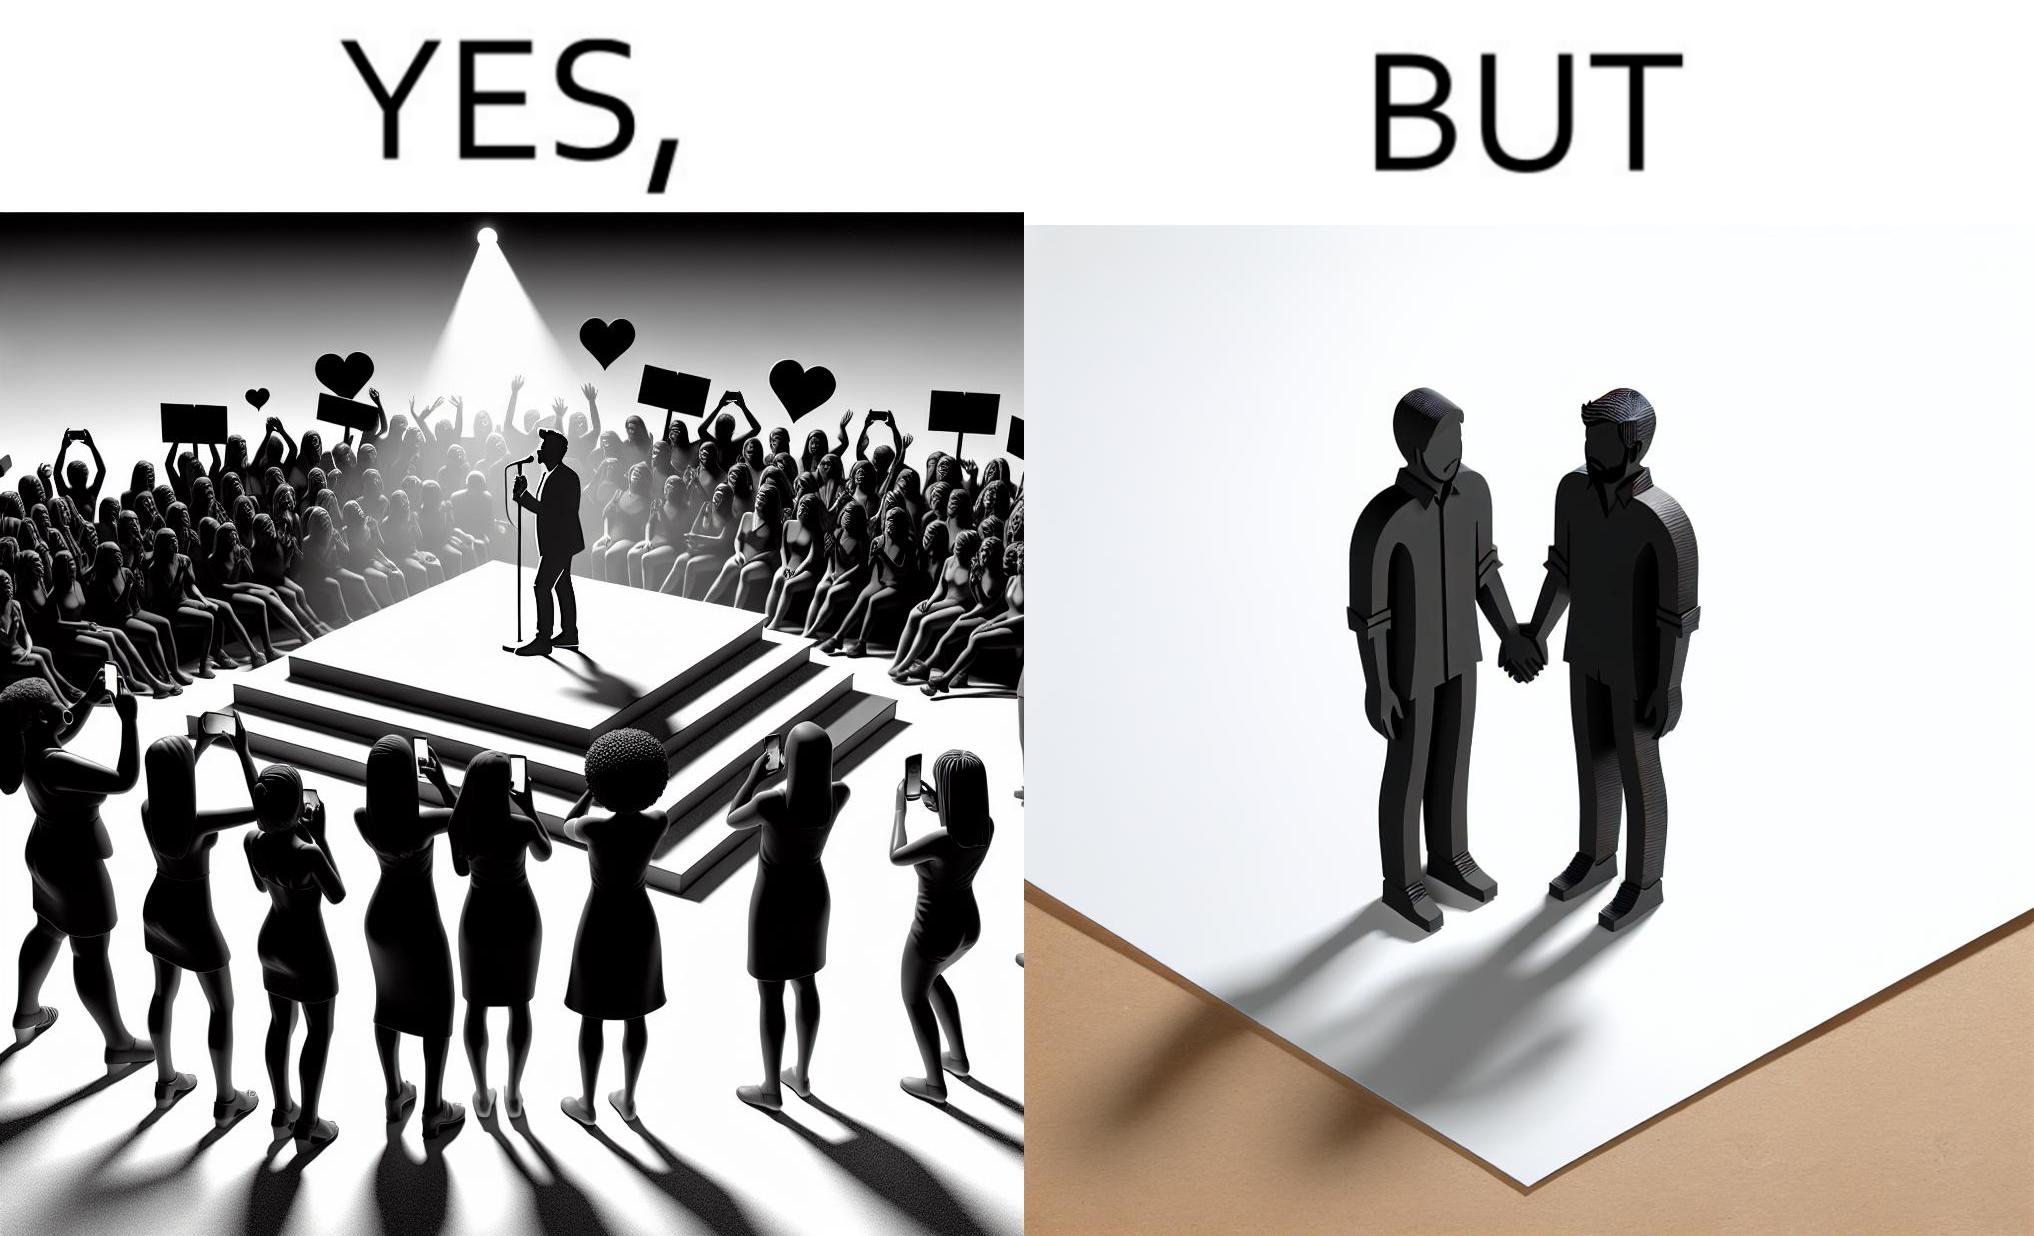Describe what you see in this image. The image is funny because while the girls loves the man, he likes other men instead of women. 